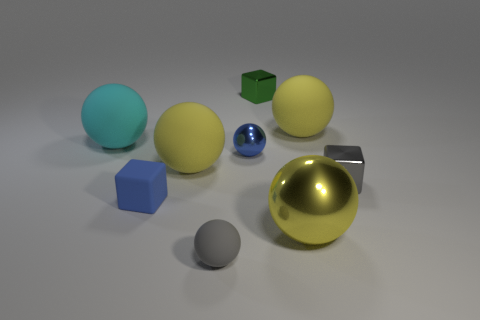Subtract all red blocks. How many yellow balls are left? 3 Subtract 1 balls. How many balls are left? 5 Subtract all blue balls. How many balls are left? 5 Subtract all yellow matte balls. How many balls are left? 4 Subtract all red balls. Subtract all gray cylinders. How many balls are left? 6 Subtract all blocks. How many objects are left? 6 Add 1 tiny blue things. How many tiny blue things exist? 3 Subtract 0 brown cylinders. How many objects are left? 9 Subtract all large cyan rubber blocks. Subtract all large yellow objects. How many objects are left? 6 Add 3 tiny spheres. How many tiny spheres are left? 5 